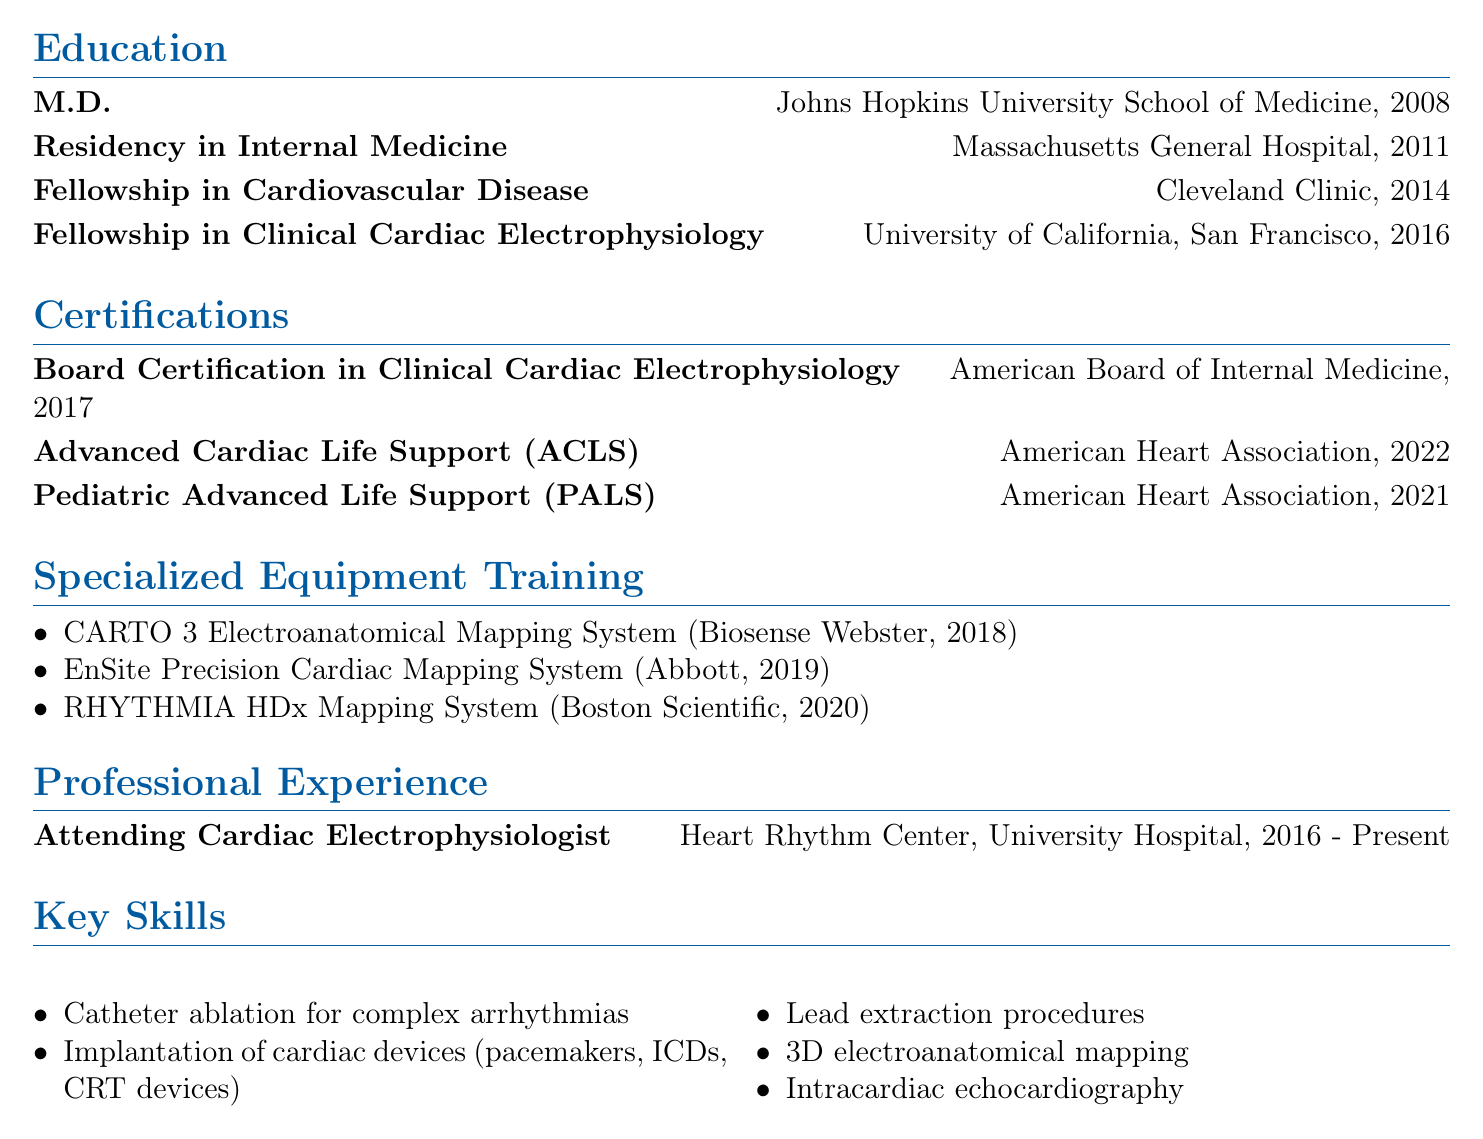What is the name of the cardiologist? The document lists "Dr. Sarah J. Thompson" as the name of the cardiologist.
Answer: Dr. Sarah J. Thompson What is the most recent certification obtained? The document states that the most recent certification, obtained in 2022, is "Advanced Cardiac Life Support (ACLS)."
Answer: Advanced Cardiac Life Support (ACLS) Which institution did Dr. Thompson attend for her fellowship in Clinical Cardiac Electrophysiology? The fellowship in Clinical Cardiac Electrophysiology was completed at the "University of California, San Francisco."
Answer: University of California, San Francisco How many years of experience does Dr. Thompson have in her current position? Dr. Thompson has been in her position as an Attending Cardiac Electrophysiologist since 2016, and the document indicates the current year is 2023, giving her approximately 7 years of experience.
Answer: 7 years Which specialized equipment did Dr. Thompson learn to operate in 2018? The document mentions that Dr. Thompson was trained on the "CARTO 3 Electroanatomical Mapping System" in 2018.
Answer: CARTO 3 Electroanatomical Mapping System What is Dr. Thompson's professional title? The document indicates that her professional title is "Cardiac Electrophysiologist."
Answer: Cardiac Electrophysiologist What type of mapping systems does Dr. Thompson have specialized training in? The document lists multiple mapping systems, including "Electroanatomical Mapping Systems."
Answer: Electroanatomical Mapping Systems What is the degree obtained by Dr. Thompson in 2008? In 2008, Dr. Thompson obtained her "M.D." degree.
Answer: M.D Which organization issued Dr. Thompson’s Board Certification in Clinical Cardiac Electrophysiology? The document states that the "American Board of Internal Medicine" issued her Board Certification.
Answer: American Board of Internal Medicine 